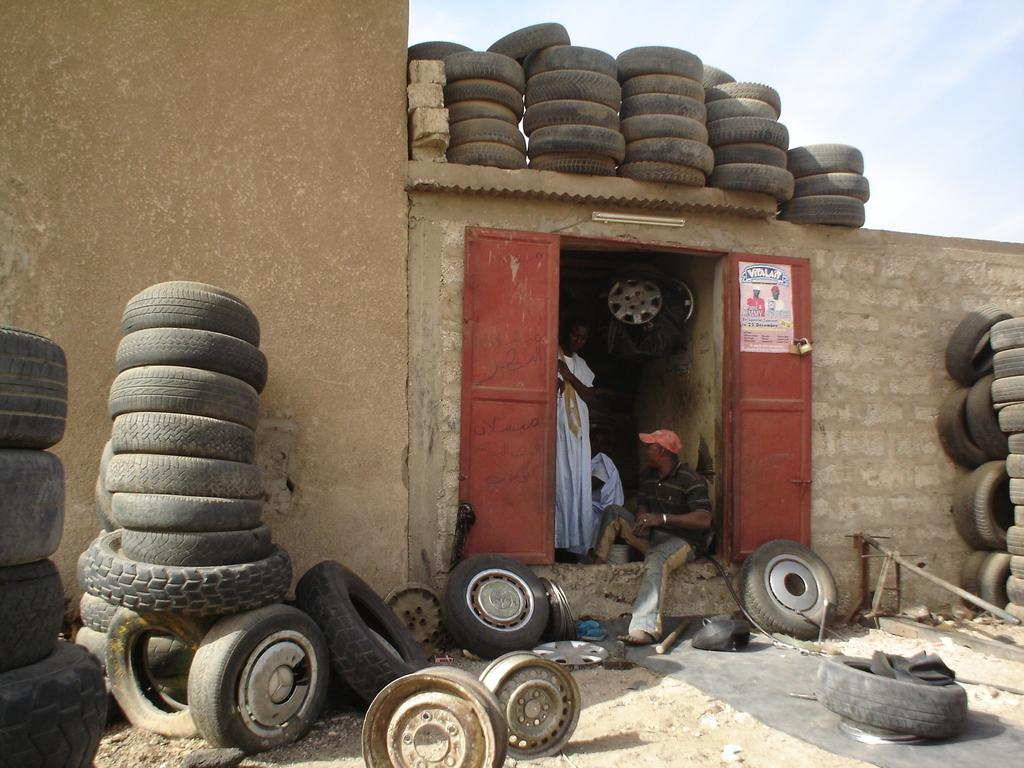What type of setting is shown in the image? The image depicts a room. How many people are present in the room? There are two persons in the room. What objects can be seen in the image besides the people? There are tires visible in the image. What is visible at the top of the image? The sky is visible at the top of the image. What type of quilt is being used to cover the tires in the image? There is no quilt present in the image, and the tires are not covered. How many stones can be seen on the floor in the image? There are no stones visible on the floor in the image. 